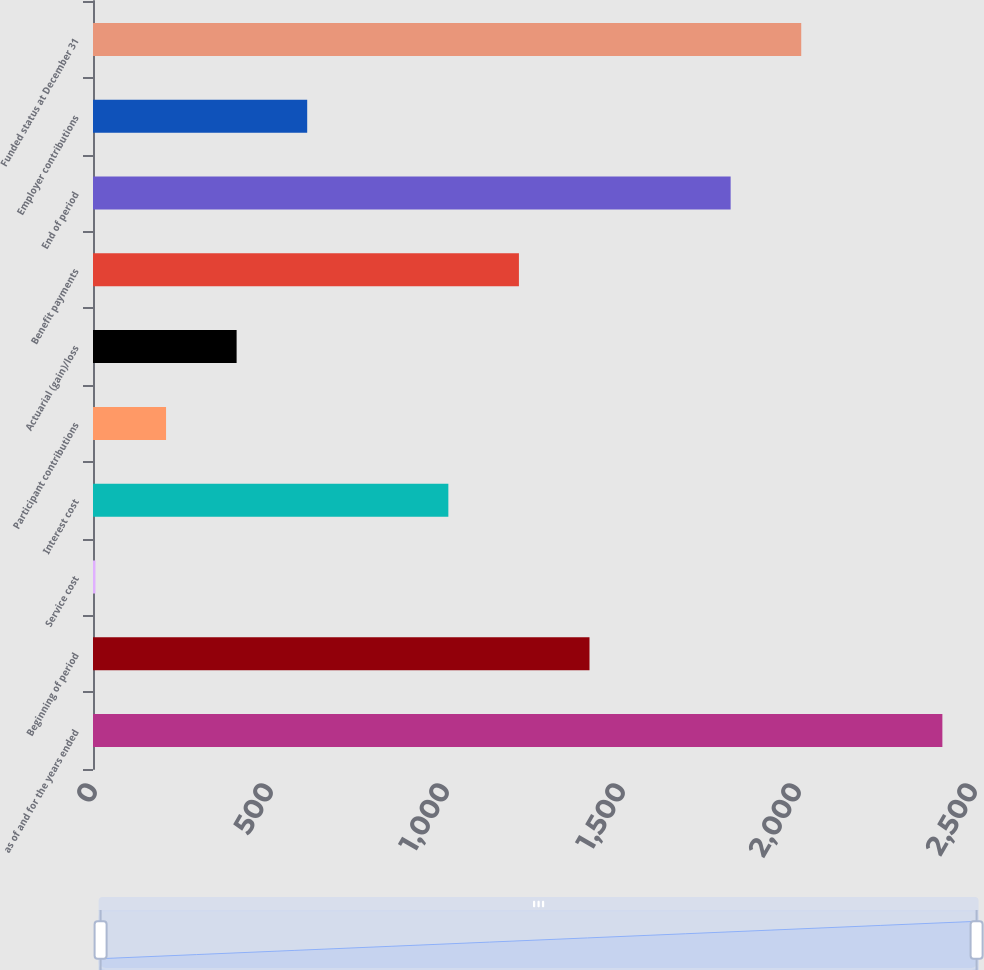Convert chart. <chart><loc_0><loc_0><loc_500><loc_500><bar_chart><fcel>as of and for the years ended<fcel>Beginning of period<fcel>Service cost<fcel>Interest cost<fcel>Participant contributions<fcel>Actuarial (gain)/loss<fcel>Benefit payments<fcel>End of period<fcel>Employer contributions<fcel>Funded status at December 31<nl><fcel>2413<fcel>1410.5<fcel>7<fcel>1009.5<fcel>207.5<fcel>408<fcel>1210<fcel>1811.5<fcel>608.5<fcel>2012<nl></chart> 